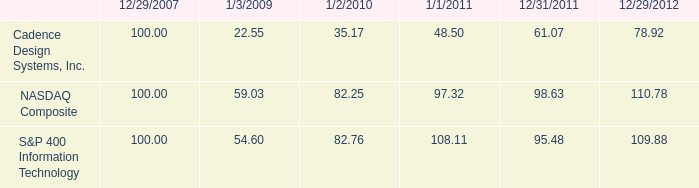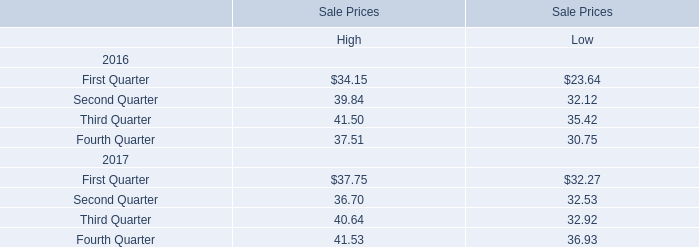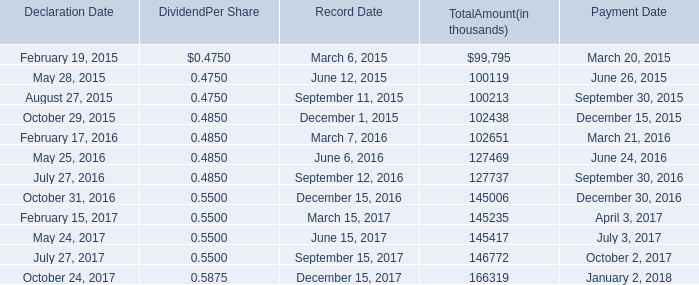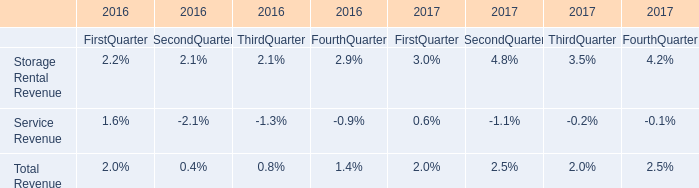What's the 50 % of the Total Amount at October 29, 2015? (in thousand) 
Computations: (0.5 * 102438)
Answer: 51219.0. 